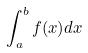Convert formula to latex. <formula><loc_0><loc_0><loc_500><loc_500>\int _ { a } ^ { b } f ( x ) d x</formula> 